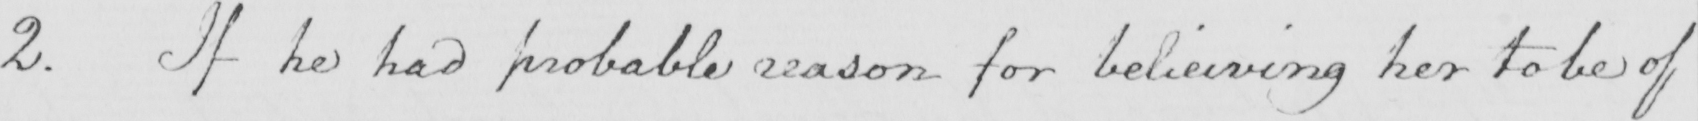What does this handwritten line say? 2 . If he had probable reason for believing her to be of 